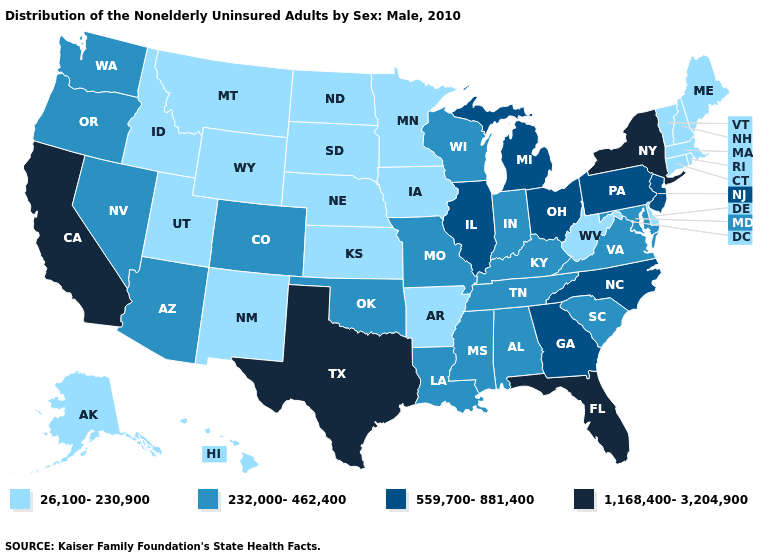What is the value of North Carolina?
Be succinct. 559,700-881,400. Is the legend a continuous bar?
Give a very brief answer. No. Does New Mexico have the lowest value in the USA?
Concise answer only. Yes. Name the states that have a value in the range 1,168,400-3,204,900?
Short answer required. California, Florida, New York, Texas. What is the value of Virginia?
Be succinct. 232,000-462,400. What is the lowest value in the South?
Be succinct. 26,100-230,900. Is the legend a continuous bar?
Keep it brief. No. Name the states that have a value in the range 559,700-881,400?
Answer briefly. Georgia, Illinois, Michigan, New Jersey, North Carolina, Ohio, Pennsylvania. Name the states that have a value in the range 26,100-230,900?
Concise answer only. Alaska, Arkansas, Connecticut, Delaware, Hawaii, Idaho, Iowa, Kansas, Maine, Massachusetts, Minnesota, Montana, Nebraska, New Hampshire, New Mexico, North Dakota, Rhode Island, South Dakota, Utah, Vermont, West Virginia, Wyoming. Among the states that border California , which have the lowest value?
Be succinct. Arizona, Nevada, Oregon. Which states have the lowest value in the MidWest?
Quick response, please. Iowa, Kansas, Minnesota, Nebraska, North Dakota, South Dakota. Does the map have missing data?
Quick response, please. No. Which states have the lowest value in the USA?
Give a very brief answer. Alaska, Arkansas, Connecticut, Delaware, Hawaii, Idaho, Iowa, Kansas, Maine, Massachusetts, Minnesota, Montana, Nebraska, New Hampshire, New Mexico, North Dakota, Rhode Island, South Dakota, Utah, Vermont, West Virginia, Wyoming. Which states have the lowest value in the Northeast?
Quick response, please. Connecticut, Maine, Massachusetts, New Hampshire, Rhode Island, Vermont. What is the highest value in states that border Mississippi?
Write a very short answer. 232,000-462,400. 